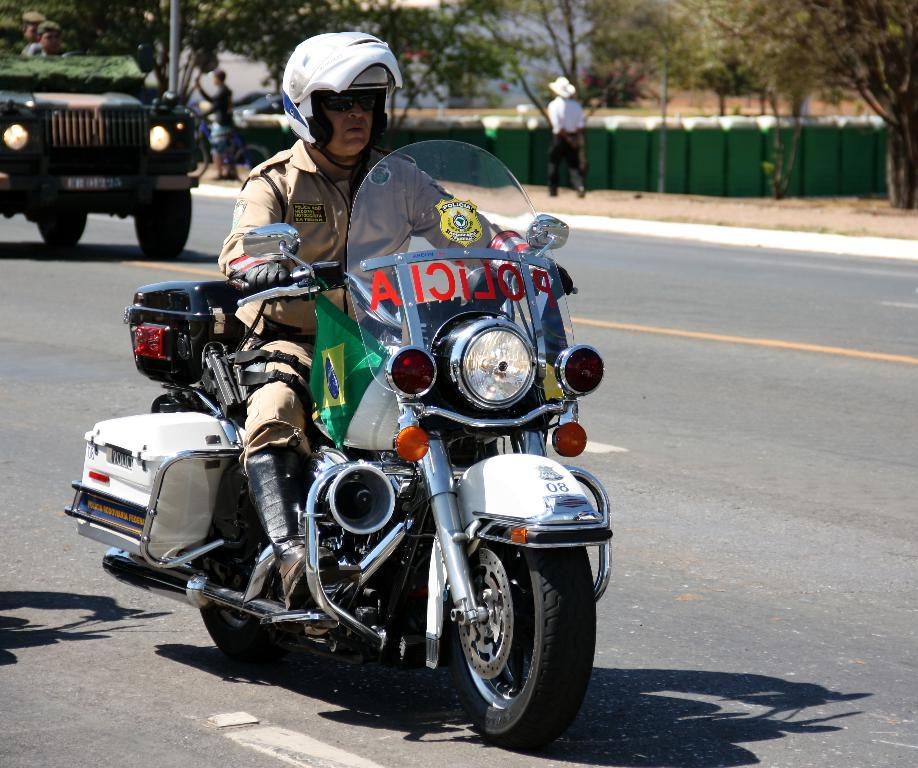What is the man in the image doing? The man is riding a bike in the image. What safety precaution is the man taking while riding the bike? The man is wearing a helmet. What other mode of transportation can be seen in the image? There is a car on the road in the image. What can be seen in the background of the image? There is a person walking in the background of the image. What type of natural scenery is visible in the image? There are trees visible in the image. What is the weight of the smoke coming out of the crook's pipe in the image? There is no smoke or crook present in the image. 